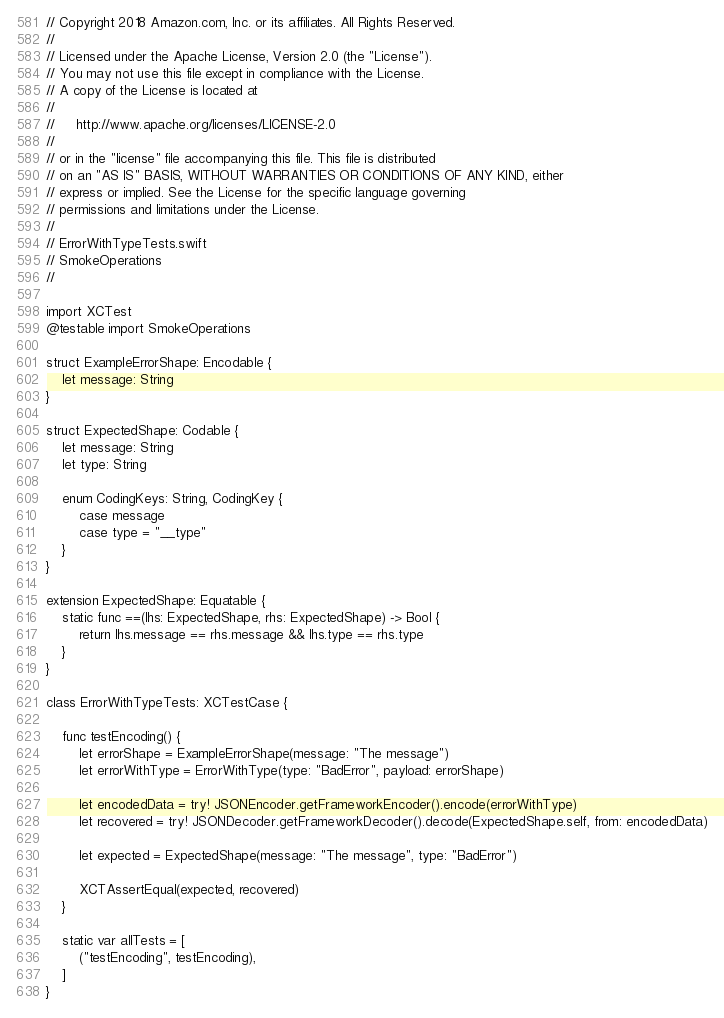<code> <loc_0><loc_0><loc_500><loc_500><_Swift_>// Copyright 2018 Amazon.com, Inc. or its affiliates. All Rights Reserved.
//
// Licensed under the Apache License, Version 2.0 (the "License").
// You may not use this file except in compliance with the License.
// A copy of the License is located at
//
//     http://www.apache.org/licenses/LICENSE-2.0
//
// or in the "license" file accompanying this file. This file is distributed
// on an "AS IS" BASIS, WITHOUT WARRANTIES OR CONDITIONS OF ANY KIND, either
// express or implied. See the License for the specific language governing
// permissions and limitations under the License.
//
// ErrorWithTypeTests.swift
// SmokeOperations
//

import XCTest
@testable import SmokeOperations

struct ExampleErrorShape: Encodable {
    let message: String
}

struct ExpectedShape: Codable {
    let message: String
    let type: String
    
    enum CodingKeys: String, CodingKey {
        case message
        case type = "__type"
    }
}

extension ExpectedShape: Equatable {
    static func ==(lhs: ExpectedShape, rhs: ExpectedShape) -> Bool {
        return lhs.message == rhs.message && lhs.type == rhs.type
    }
}

class ErrorWithTypeTests: XCTestCase {

    func testEncoding() {
        let errorShape = ExampleErrorShape(message: "The message")
        let errorWithType = ErrorWithType(type: "BadError", payload: errorShape)
        
        let encodedData = try! JSONEncoder.getFrameworkEncoder().encode(errorWithType)
        let recovered = try! JSONDecoder.getFrameworkDecoder().decode(ExpectedShape.self, from: encodedData)
        
        let expected = ExpectedShape(message: "The message", type: "BadError")
        
        XCTAssertEqual(expected, recovered)
    }

    static var allTests = [
        ("testEncoding", testEncoding),
    ]
}
</code> 